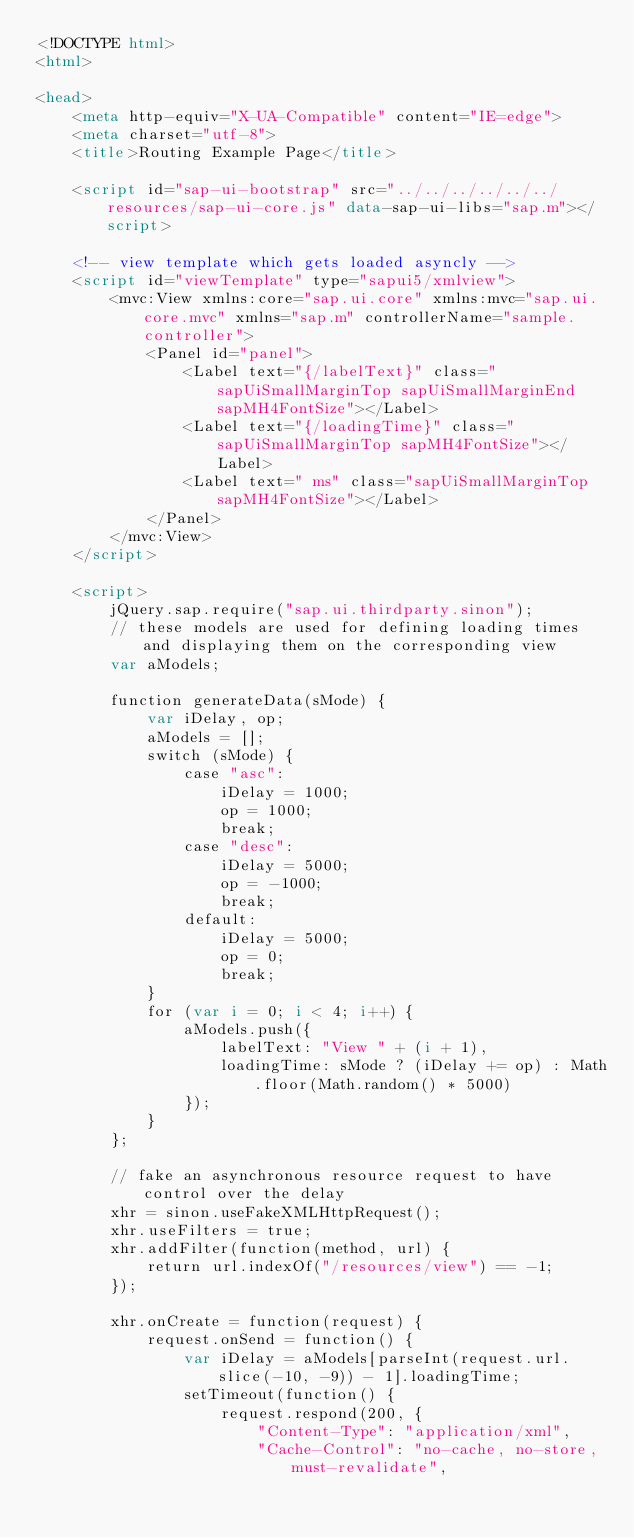Convert code to text. <code><loc_0><loc_0><loc_500><loc_500><_HTML_><!DOCTYPE html>
<html>

<head>
	<meta http-equiv="X-UA-Compatible" content="IE=edge">
	<meta charset="utf-8">
	<title>Routing Example Page</title>

	<script id="sap-ui-bootstrap" src="../../../../../../resources/sap-ui-core.js" data-sap-ui-libs="sap.m"></script>

	<!-- view template which gets loaded asyncly -->
	<script id="viewTemplate" type="sapui5/xmlview">
		<mvc:View xmlns:core="sap.ui.core" xmlns:mvc="sap.ui.core.mvc" xmlns="sap.m" controllerName="sample.controller">
			<Panel id="panel">
				<Label text="{/labelText}" class="sapUiSmallMarginTop sapUiSmallMarginEnd sapMH4FontSize"></Label>
				<Label text="{/loadingTime}" class="sapUiSmallMarginTop sapMH4FontSize"></Label>
				<Label text=" ms" class="sapUiSmallMarginTop sapMH4FontSize"></Label>
			</Panel>
		</mvc:View>
	</script>

	<script>
		jQuery.sap.require("sap.ui.thirdparty.sinon");
		// these models are used for defining loading times and displaying them on the corresponding view
		var aModels;

		function generateData(sMode) {
			var iDelay, op;
			aModels = [];
			switch (sMode) {
				case "asc":
					iDelay = 1000;
					op = 1000;
					break;
				case "desc":
					iDelay = 5000;
					op = -1000;
					break;
				default:
					iDelay = 5000;
					op = 0;
					break;
			}
			for (var i = 0; i < 4; i++) {
				aModels.push({
					labelText: "View " + (i + 1),
					loadingTime: sMode ? (iDelay += op) : Math.floor(Math.random() * 5000)
				});
			}
		};

		// fake an asynchronous resource request to have control over the delay
		xhr = sinon.useFakeXMLHttpRequest();
		xhr.useFilters = true;
		xhr.addFilter(function(method, url) {
			return url.indexOf("/resources/view") == -1;
		});

		xhr.onCreate = function(request) {
			request.onSend = function() {
				var iDelay = aModels[parseInt(request.url.slice(-10, -9)) - 1].loadingTime;
				setTimeout(function() {
					request.respond(200, {
						"Content-Type": "application/xml",
						"Cache-Control": "no-cache, no-store, must-revalidate",</code> 